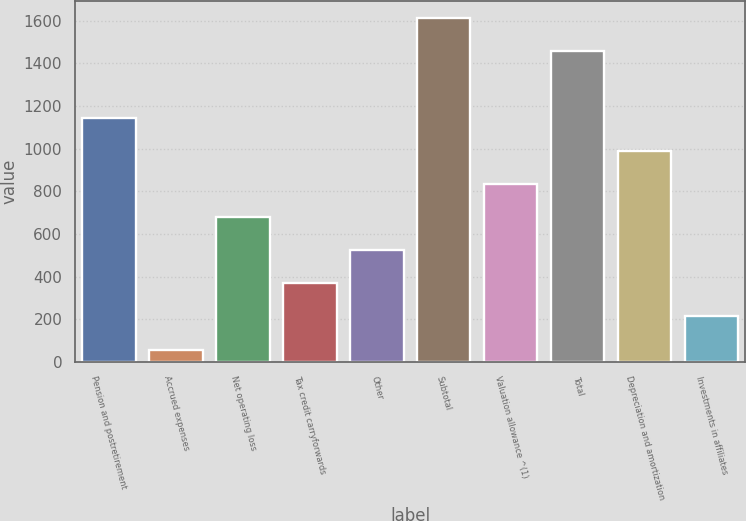Convert chart to OTSL. <chart><loc_0><loc_0><loc_500><loc_500><bar_chart><fcel>Pension and postretirement<fcel>Accrued expenses<fcel>Net operating loss<fcel>Tax credit carryforwards<fcel>Other<fcel>Subtotal<fcel>Valuation allowance ^(1)<fcel>Total<fcel>Depreciation and amortization<fcel>Investments in affiliates<nl><fcel>1145.1<fcel>58<fcel>679.2<fcel>368.6<fcel>523.9<fcel>1611<fcel>834.5<fcel>1455.7<fcel>989.8<fcel>213.3<nl></chart> 